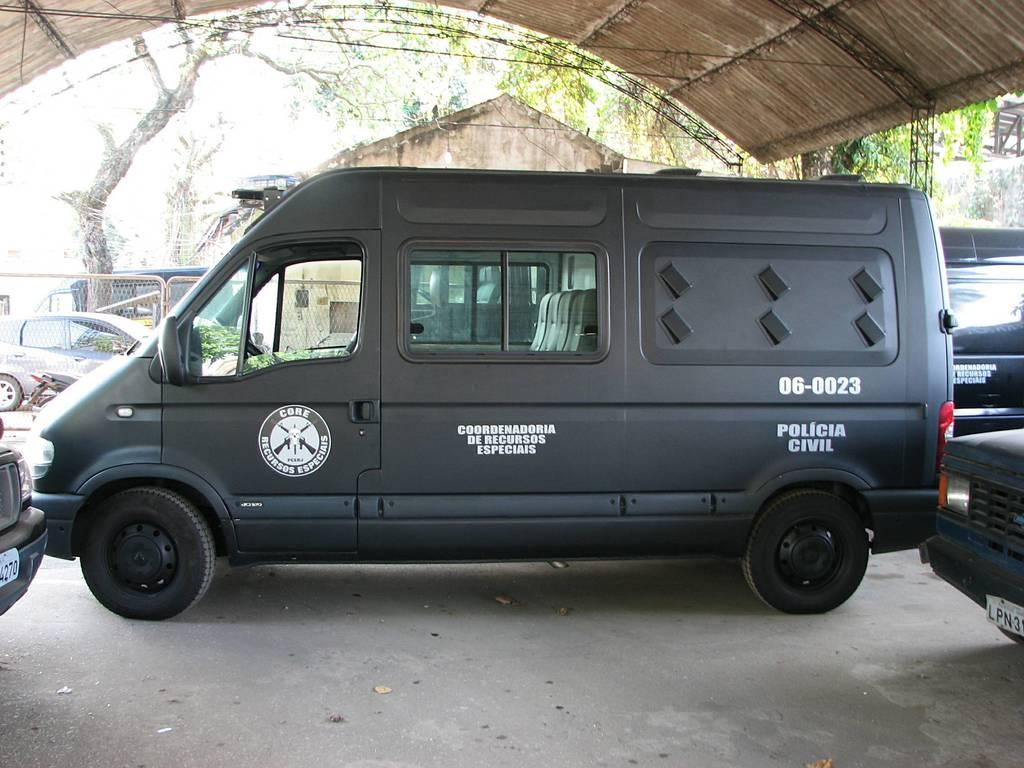<image>
Offer a succinct explanation of the picture presented. A black van has a seal on the door that says "core recursos especiais". 